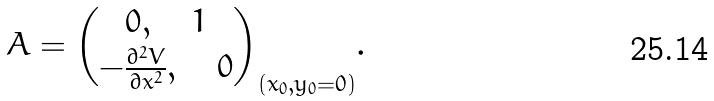<formula> <loc_0><loc_0><loc_500><loc_500>A = { 0 , \quad 1 \choose - \frac { \partial ^ { 2 } V } { \partial x ^ { 2 } } , \quad 0 } _ { ( x _ { 0 } , y _ { 0 } = 0 ) } .</formula> 